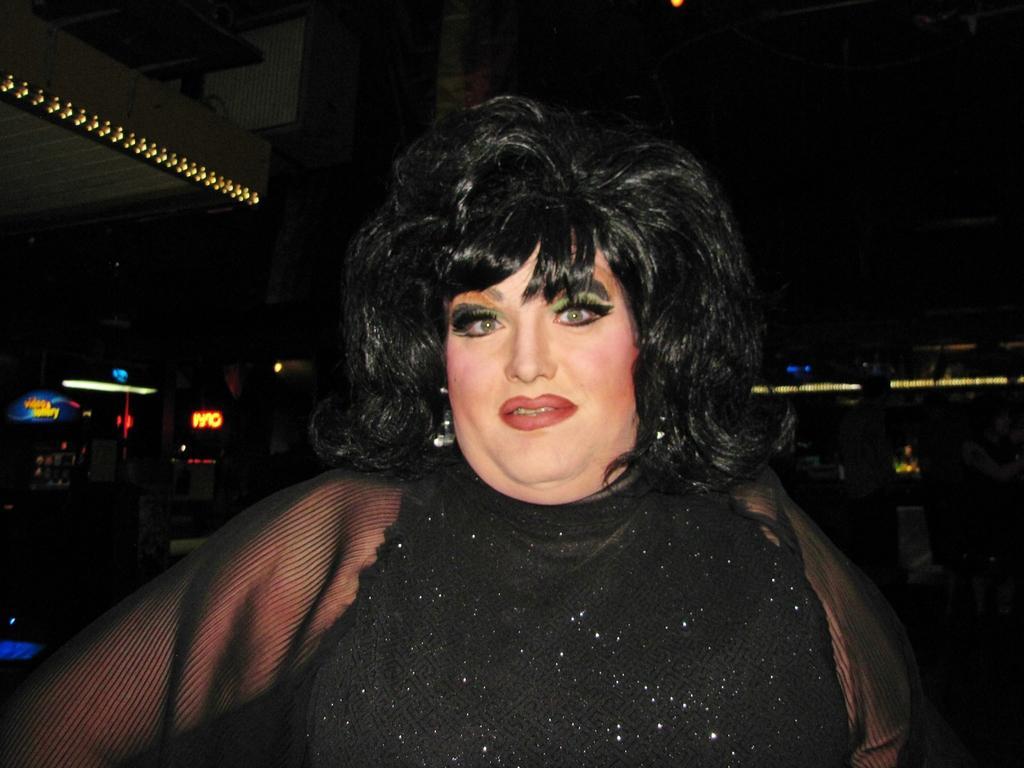Could you give a brief overview of what you see in this image? In the picture we can see a woman wearing a black dress and it is shining and in the background we can see some lights in the dark. 